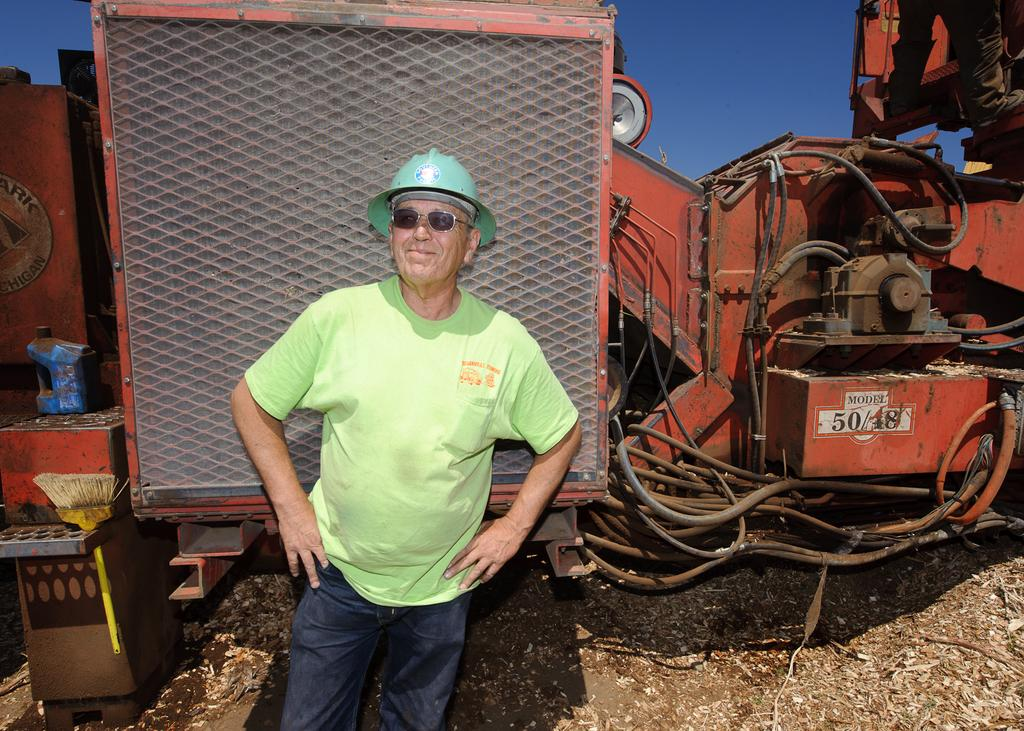Who is present in the image? There is a man in the image. What is the man wearing on his face? The man is wearing spectacles. What is the man wearing on his head? The man is wearing a helmet. What object can be seen in the image that is typically used for cleaning or painting? There is a brush in the image. What object can be seen in the image that is typically used for holding liquids? There is a can in the image. What type of large object is present in the image that can be used for transportation? There is a vehicle in the image. Where is the sail located in the image? There is no sail present in the image. What type of container is the mom using to carry water in the image? There is no mom or container for water present in the image. 